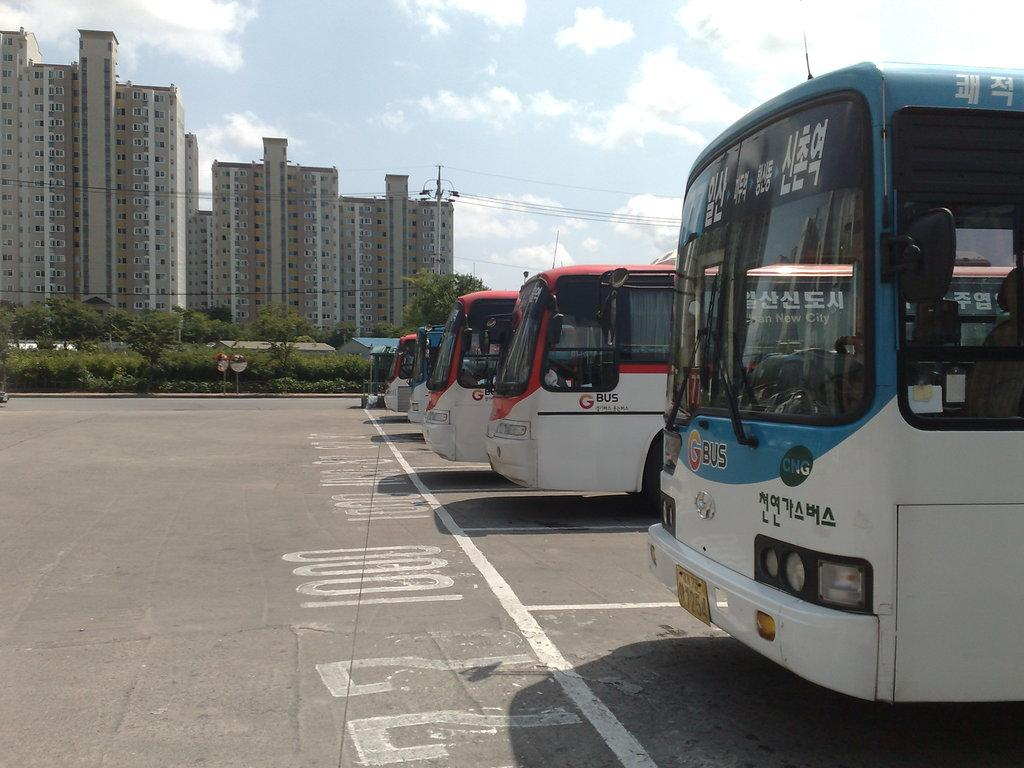Provide a one-sentence caption for the provided image. Several busses made by GBus sit in a parking lot. 